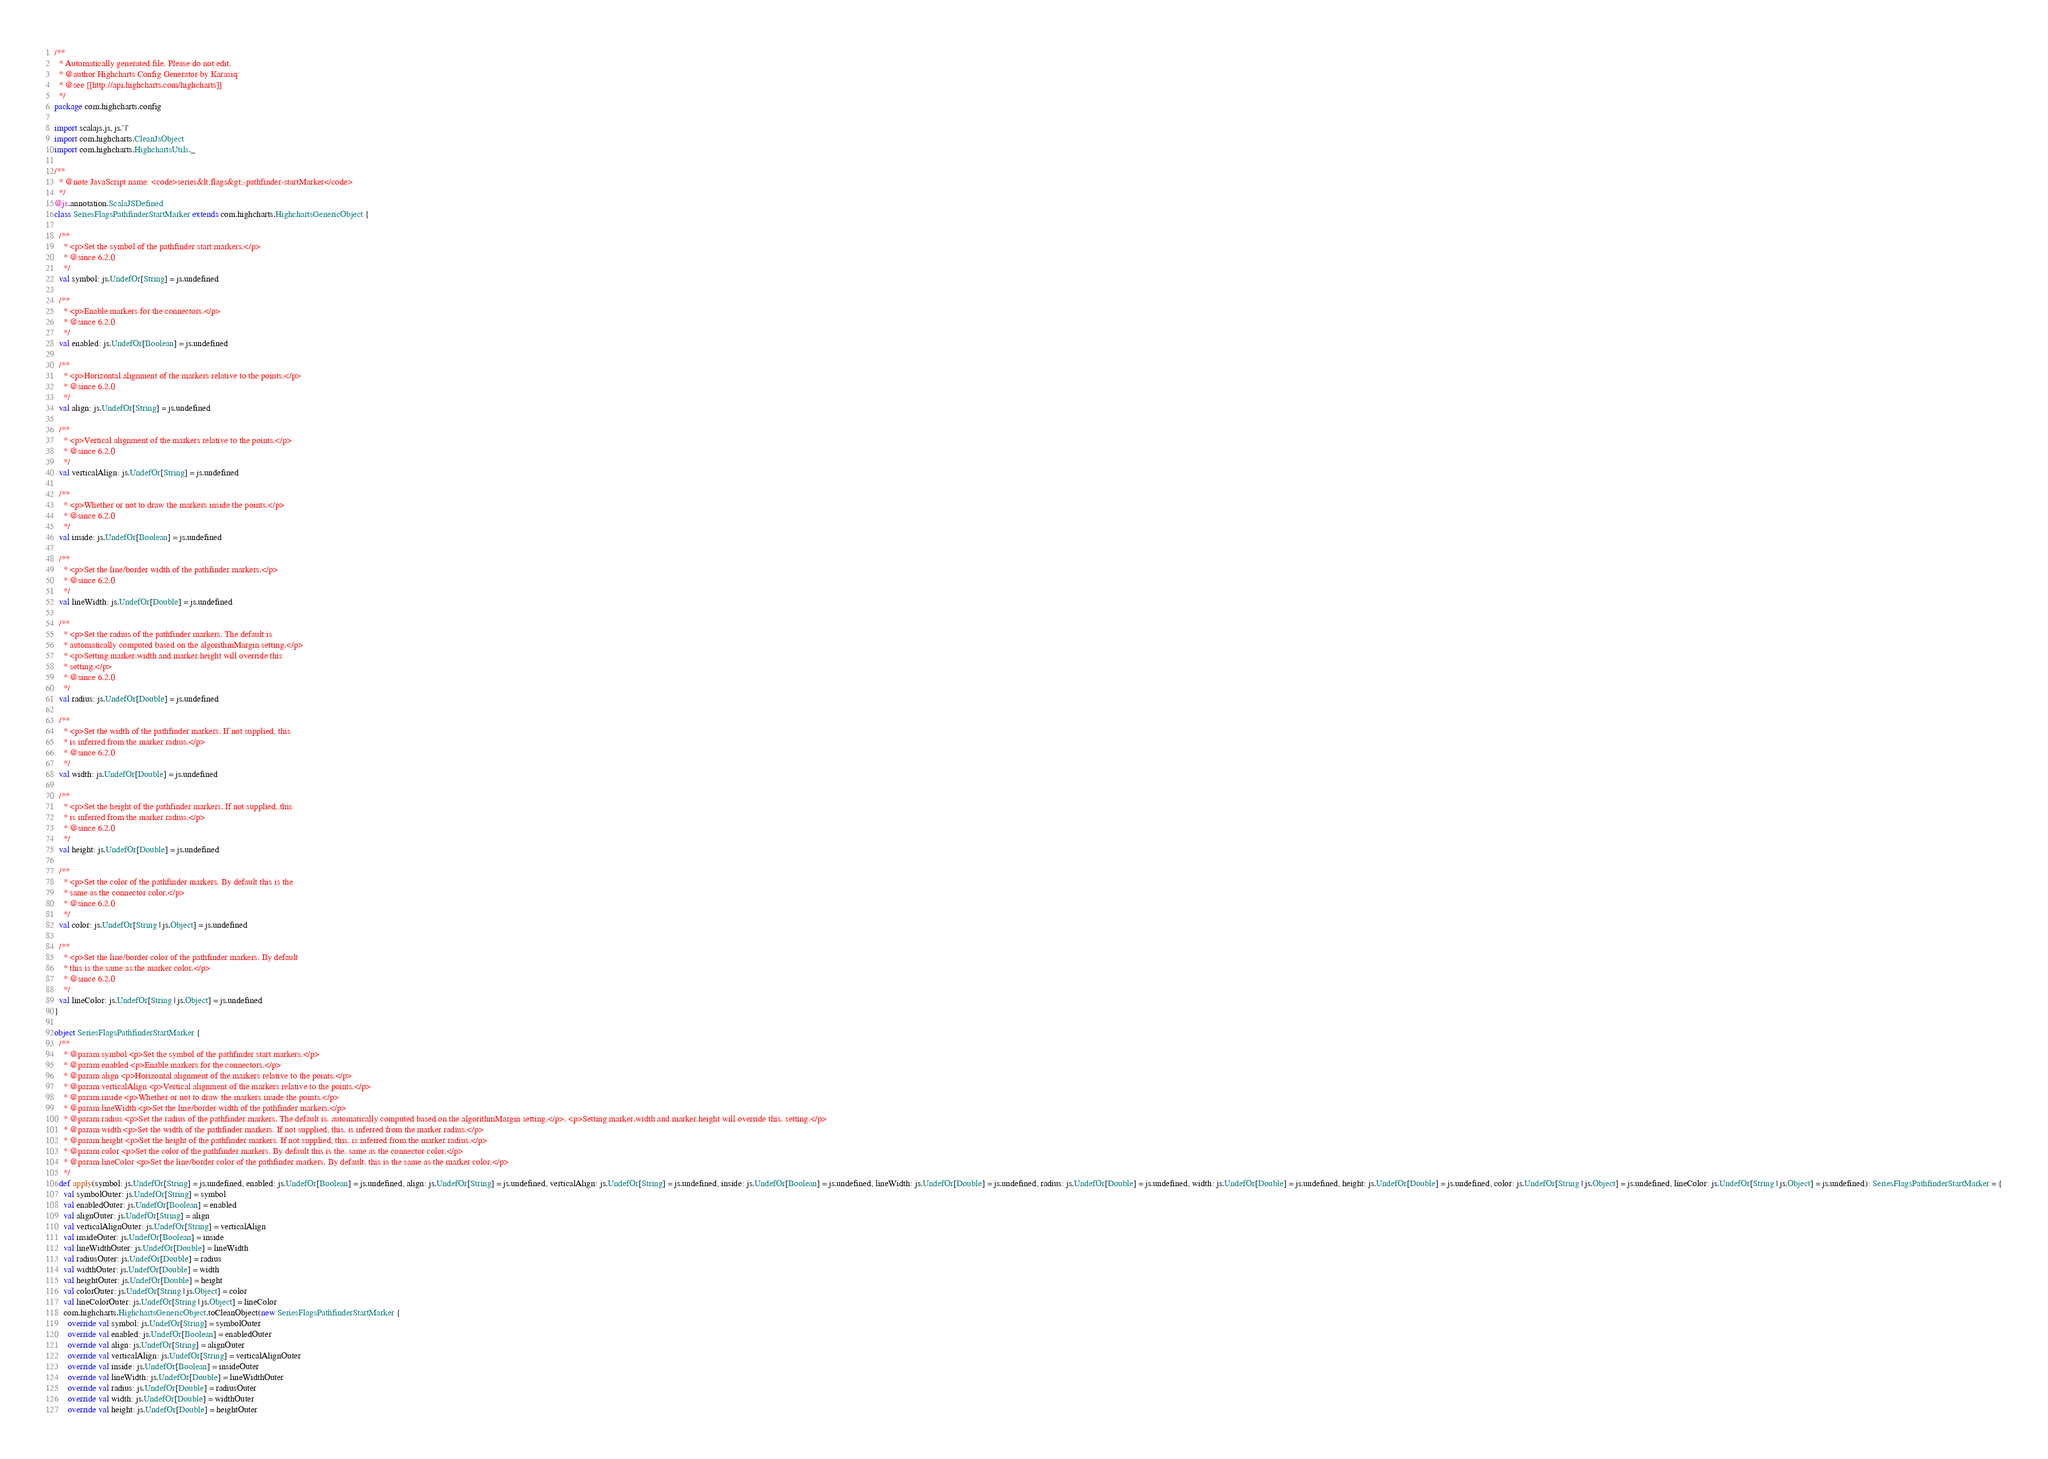Convert code to text. <code><loc_0><loc_0><loc_500><loc_500><_Scala_>/**
  * Automatically generated file. Please do not edit.
  * @author Highcharts Config Generator by Karasiq
  * @see [[http://api.highcharts.com/highcharts]]
  */
package com.highcharts.config

import scalajs.js, js.`|`
import com.highcharts.CleanJsObject
import com.highcharts.HighchartsUtils._

/**
  * @note JavaScript name: <code>series&lt;flags&gt;-pathfinder-startMarker</code>
  */
@js.annotation.ScalaJSDefined
class SeriesFlagsPathfinderStartMarker extends com.highcharts.HighchartsGenericObject {

  /**
    * <p>Set the symbol of the pathfinder start markers.</p>
    * @since 6.2.0
    */
  val symbol: js.UndefOr[String] = js.undefined

  /**
    * <p>Enable markers for the connectors.</p>
    * @since 6.2.0
    */
  val enabled: js.UndefOr[Boolean] = js.undefined

  /**
    * <p>Horizontal alignment of the markers relative to the points.</p>
    * @since 6.2.0
    */
  val align: js.UndefOr[String] = js.undefined

  /**
    * <p>Vertical alignment of the markers relative to the points.</p>
    * @since 6.2.0
    */
  val verticalAlign: js.UndefOr[String] = js.undefined

  /**
    * <p>Whether or not to draw the markers inside the points.</p>
    * @since 6.2.0
    */
  val inside: js.UndefOr[Boolean] = js.undefined

  /**
    * <p>Set the line/border width of the pathfinder markers.</p>
    * @since 6.2.0
    */
  val lineWidth: js.UndefOr[Double] = js.undefined

  /**
    * <p>Set the radius of the pathfinder markers. The default is
    * automatically computed based on the algorithmMargin setting.</p>
    * <p>Setting marker.width and marker.height will override this
    * setting.</p>
    * @since 6.2.0
    */
  val radius: js.UndefOr[Double] = js.undefined

  /**
    * <p>Set the width of the pathfinder markers. If not supplied, this
    * is inferred from the marker radius.</p>
    * @since 6.2.0
    */
  val width: js.UndefOr[Double] = js.undefined

  /**
    * <p>Set the height of the pathfinder markers. If not supplied, this
    * is inferred from the marker radius.</p>
    * @since 6.2.0
    */
  val height: js.UndefOr[Double] = js.undefined

  /**
    * <p>Set the color of the pathfinder markers. By default this is the
    * same as the connector color.</p>
    * @since 6.2.0
    */
  val color: js.UndefOr[String | js.Object] = js.undefined

  /**
    * <p>Set the line/border color of the pathfinder markers. By default
    * this is the same as the marker color.</p>
    * @since 6.2.0
    */
  val lineColor: js.UndefOr[String | js.Object] = js.undefined
}

object SeriesFlagsPathfinderStartMarker {
  /**
    * @param symbol <p>Set the symbol of the pathfinder start markers.</p>
    * @param enabled <p>Enable markers for the connectors.</p>
    * @param align <p>Horizontal alignment of the markers relative to the points.</p>
    * @param verticalAlign <p>Vertical alignment of the markers relative to the points.</p>
    * @param inside <p>Whether or not to draw the markers inside the points.</p>
    * @param lineWidth <p>Set the line/border width of the pathfinder markers.</p>
    * @param radius <p>Set the radius of the pathfinder markers. The default is. automatically computed based on the algorithmMargin setting.</p>. <p>Setting marker.width and marker.height will override this. setting.</p>
    * @param width <p>Set the width of the pathfinder markers. If not supplied, this. is inferred from the marker radius.</p>
    * @param height <p>Set the height of the pathfinder markers. If not supplied, this. is inferred from the marker radius.</p>
    * @param color <p>Set the color of the pathfinder markers. By default this is the. same as the connector color.</p>
    * @param lineColor <p>Set the line/border color of the pathfinder markers. By default. this is the same as the marker color.</p>
    */
  def apply(symbol: js.UndefOr[String] = js.undefined, enabled: js.UndefOr[Boolean] = js.undefined, align: js.UndefOr[String] = js.undefined, verticalAlign: js.UndefOr[String] = js.undefined, inside: js.UndefOr[Boolean] = js.undefined, lineWidth: js.UndefOr[Double] = js.undefined, radius: js.UndefOr[Double] = js.undefined, width: js.UndefOr[Double] = js.undefined, height: js.UndefOr[Double] = js.undefined, color: js.UndefOr[String | js.Object] = js.undefined, lineColor: js.UndefOr[String | js.Object] = js.undefined): SeriesFlagsPathfinderStartMarker = {
    val symbolOuter: js.UndefOr[String] = symbol
    val enabledOuter: js.UndefOr[Boolean] = enabled
    val alignOuter: js.UndefOr[String] = align
    val verticalAlignOuter: js.UndefOr[String] = verticalAlign
    val insideOuter: js.UndefOr[Boolean] = inside
    val lineWidthOuter: js.UndefOr[Double] = lineWidth
    val radiusOuter: js.UndefOr[Double] = radius
    val widthOuter: js.UndefOr[Double] = width
    val heightOuter: js.UndefOr[Double] = height
    val colorOuter: js.UndefOr[String | js.Object] = color
    val lineColorOuter: js.UndefOr[String | js.Object] = lineColor
    com.highcharts.HighchartsGenericObject.toCleanObject(new SeriesFlagsPathfinderStartMarker {
      override val symbol: js.UndefOr[String] = symbolOuter
      override val enabled: js.UndefOr[Boolean] = enabledOuter
      override val align: js.UndefOr[String] = alignOuter
      override val verticalAlign: js.UndefOr[String] = verticalAlignOuter
      override val inside: js.UndefOr[Boolean] = insideOuter
      override val lineWidth: js.UndefOr[Double] = lineWidthOuter
      override val radius: js.UndefOr[Double] = radiusOuter
      override val width: js.UndefOr[Double] = widthOuter
      override val height: js.UndefOr[Double] = heightOuter</code> 